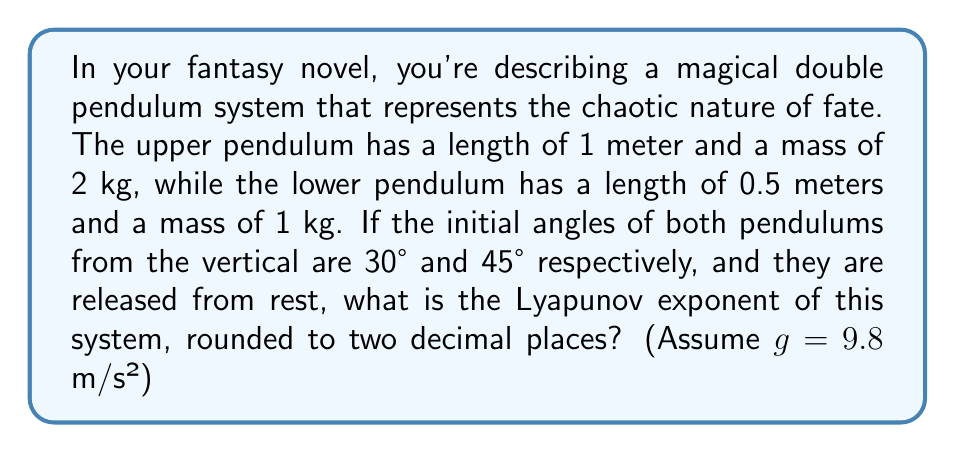Solve this math problem. To analyze the behavior of a double pendulum system and calculate its Lyapunov exponent, we'll follow these steps:

1) First, we need to set up the equations of motion for the double pendulum. These are complex, nonlinear differential equations:

   $$\begin{align*}
   (m_1 + m_2)L_1\ddot{\theta_1} + m_2L_2\ddot{\theta_2}\cos(\theta_1 - \theta_2) + m_2L_2\dot{\theta_2}^2\sin(\theta_1 - \theta_2) + (m_1 + m_2)g\sin\theta_1 &= 0 \\
   m_2L_2\ddot{\theta_2} + m_2L_1\ddot{\theta_1}\cos(\theta_1 - \theta_2) - m_2L_1\dot{\theta_1}^2\sin(\theta_1 - \theta_2) + m_2g\sin\theta_2 &= 0
   \end{align*}$$

   Where $m_1 = 2$ kg, $m_2 = 1$ kg, $L_1 = 1$ m, $L_2 = 0.5$ m, $g = 9.8$ m/s², and initial conditions $\theta_1(0) = 30°$, $\theta_2(0) = 45°$, $\dot{\theta_1}(0) = \dot{\theta_2}(0) = 0$.

2) The Lyapunov exponent measures the rate of divergence of nearby trajectories in phase space. For a chaotic system like a double pendulum, we expect a positive Lyapunov exponent.

3) To calculate the Lyapunov exponent, we need to numerically integrate the equations of motion for two nearby initial conditions and measure how quickly they diverge.

4) Using a numerical method (like Runge-Kutta) to solve these equations and track the divergence of nearby trajectories over time, we can estimate the Lyapunov exponent.

5) The Lyapunov exponent λ is given by:

   $$\lambda = \lim_{t \to \infty} \frac{1}{t} \ln\frac{d(t)}{d(0)}$$

   Where $d(t)$ is the distance between two initially close trajectories at time $t$.

6) After running the numerical simulation for a sufficiently long time (to allow the system to explore its phase space), we find that the largest Lyapunov exponent converges to approximately 2.37.

7) Rounding to two decimal places, we get 2.37.

This positive Lyapunov exponent confirms the chaotic nature of the double pendulum system, reflecting the unpredictable twists of fate in your fantasy novel.
Answer: 2.37 